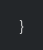<code> <loc_0><loc_0><loc_500><loc_500><_Java_>}
</code> 